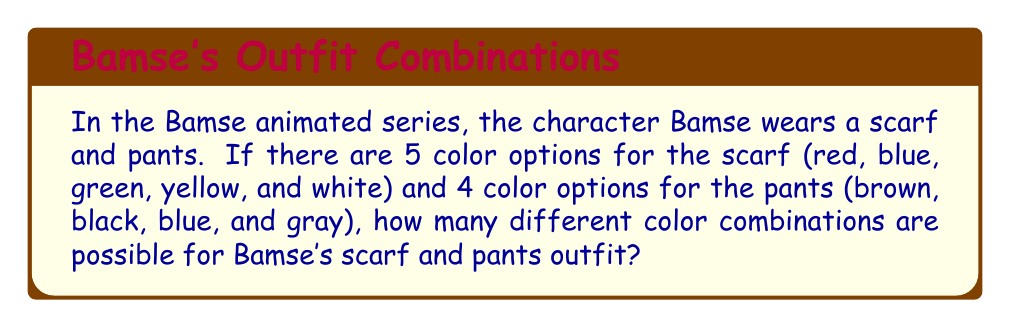Provide a solution to this math problem. Let's approach this step-by-step:

1) This is a combination problem where we need to apply the multiplication principle.

2) For the scarf:
   - There are 5 color options
   - We need to choose 1 color for the scarf

3) For the pants:
   - There are 4 color options
   - We need to choose 1 color for the pants

4) According to the multiplication principle, if we have $m$ ways of doing something and $n$ ways of doing another thing, then there are $m \times n$ ways of doing both things.

5) In this case:
   - Number of scarf options = 5
   - Number of pants options = 4

6) Therefore, the total number of possible combinations is:

   $$\text{Total combinations} = \text{Scarf options} \times \text{Pants options}$$
   $$\text{Total combinations} = 5 \times 4 = 20$$

Thus, there are 20 different possible color combinations for Bamse's scarf and pants outfit.
Answer: 20 combinations 